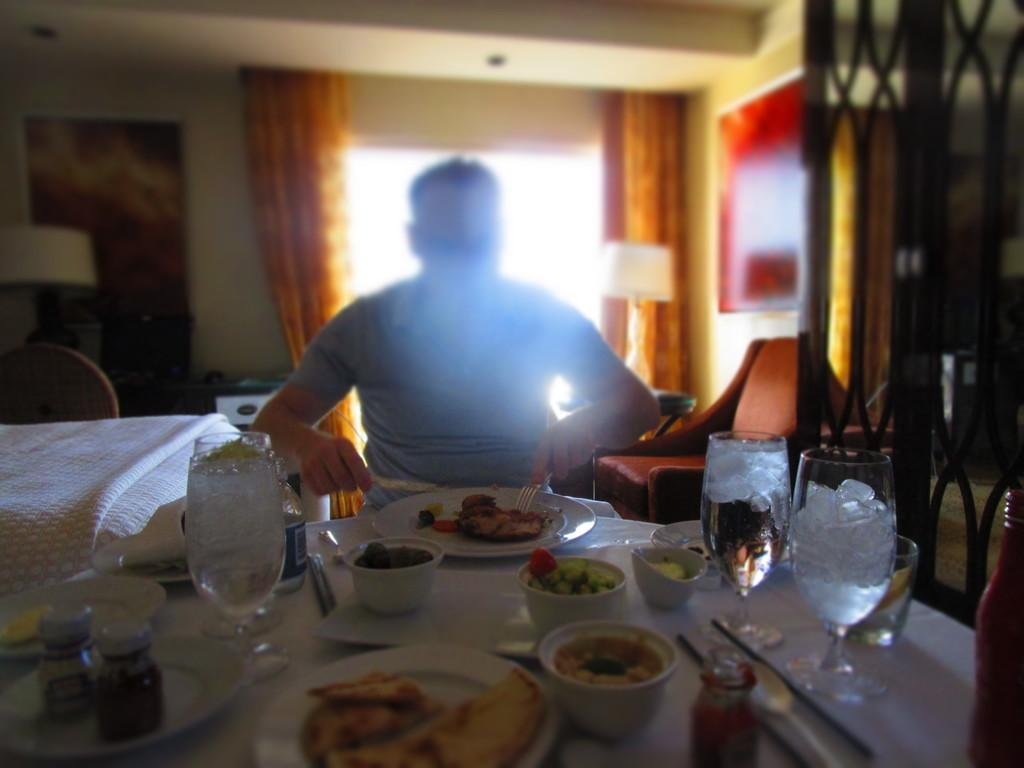What is the main subject of the image? There is a person in the image. Can you describe the person's clothing? The person is wearing a blue shirt. Where is the person sitting in relation to the table? The person is sitting in front of a table. What can be found on the table? The table contains eatables. What piece of furniture is located beside the person? There is a bed beside the person. What is visible behind the person? There is a window behind the person. What type of town can be seen through the window in the image? There is no town visible through the window in the image; only a window is present. Is there a banana on the table in the image? The provided facts do not mention a banana on the table, so we cannot confirm its presence. 